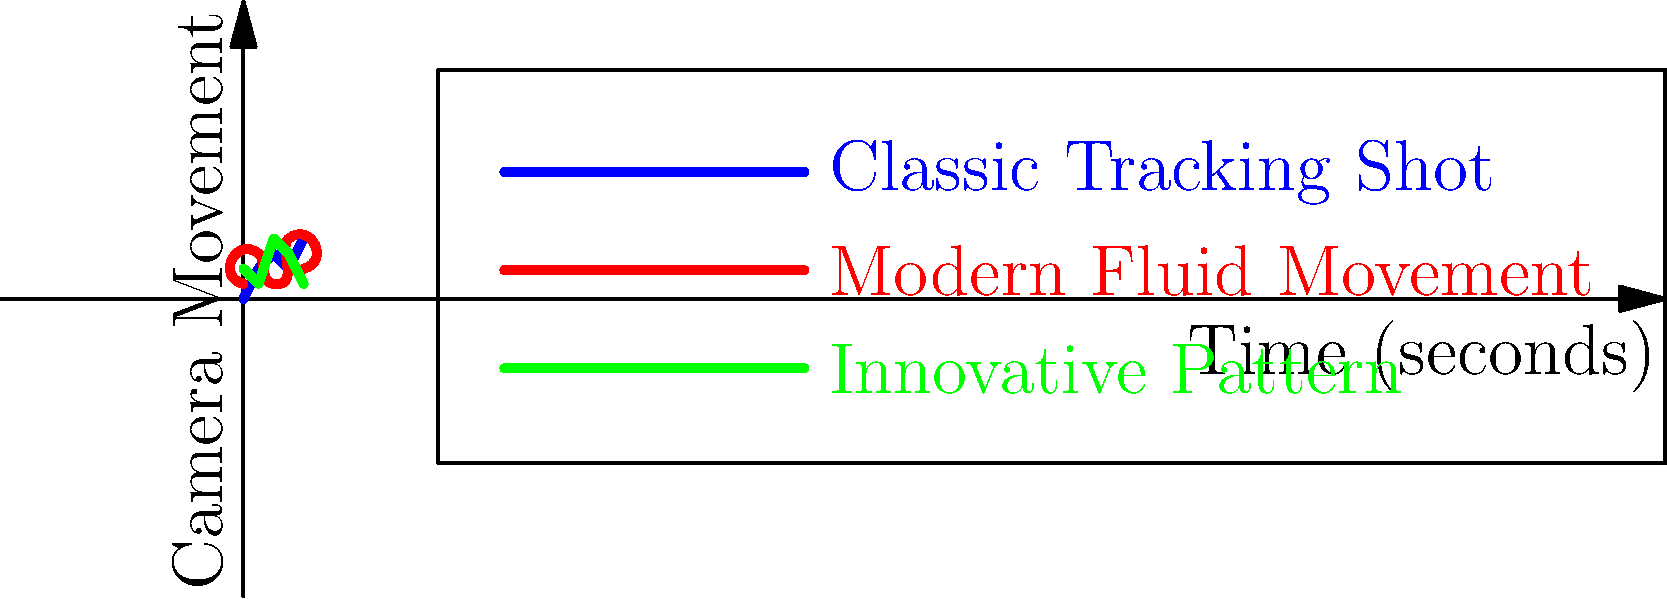As a film director influenced by classic cinema, analyze the three camera movement patterns shown in the graph. Which pattern most closely resembles the iconic tracking shot in Orson Welles' "Touch of Evil" (1958), and how does it contribute to the film's narrative tension? To answer this question, let's break down the analysis:

1. Understand the graph:
   - The x-axis represents time in seconds.
   - The y-axis represents camera movement (higher values indicate more movement).
   - Three patterns are shown: Classic Tracking Shot (blue), Modern Fluid Movement (red), and Innovative Pattern (green).

2. Recall "Touch of Evil" opening shot:
   - It's a famous 3-minute, 20-second uninterrupted tracking shot.
   - The camera moves steadily, following characters through a busy border town.

3. Analyze the patterns:
   - Classic Tracking Shot (blue): Shows a steady increase with minor fluctuations.
   - Modern Fluid Movement (red): Has more dramatic curves and changes in direction.
   - Innovative Pattern (green): Shows abrupt changes and inconsistent movement.

4. Match the shot to the pattern:
   - The blue line (Classic Tracking Shot) most closely resembles the "Touch of Evil" opening.
   - It shows a generally steady progression with slight variations, mirroring the consistent yet dynamic nature of Welles' shot.

5. Consider narrative contribution:
   - The steady, relentless movement builds tension by:
     a) Establishing the setting and introducing characters without cuts.
     b) Creating a sense of inevitability as it follows the car with the bomb.
     c) Immersing the audience in real-time, unbroken action.

6. Reflect on classic influence:
   - This shot exemplifies the long-take aesthetic of classic cinema.
   - It showcases technical mastery and narrative efficiency, hallmarks of influential filmmakers like Welles.
Answer: Classic Tracking Shot pattern; builds tension through steady, unbroken movement. 